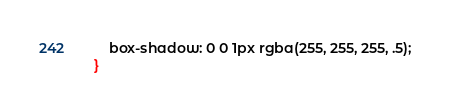<code> <loc_0><loc_0><loc_500><loc_500><_CSS_>    box-shadow: 0 0 1px rgba(255, 255, 255, .5);
}</code> 